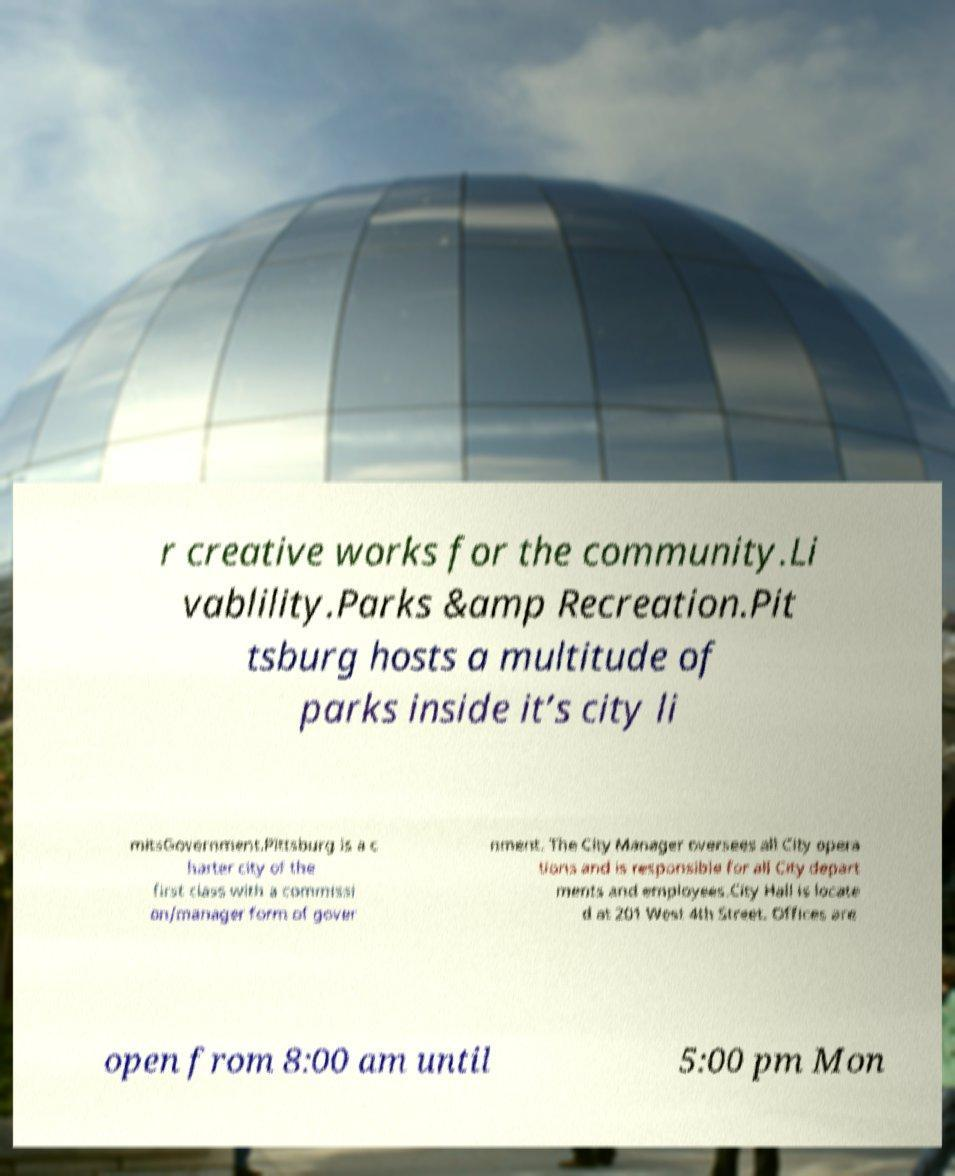Please identify and transcribe the text found in this image. r creative works for the community.Li vablility.Parks &amp Recreation.Pit tsburg hosts a multitude of parks inside it’s city li mitsGovernment.Pittsburg is a c harter city of the first class with a commissi on/manager form of gover nment. The City Manager oversees all City opera tions and is responsible for all City depart ments and employees.City Hall is locate d at 201 West 4th Street. Offices are open from 8:00 am until 5:00 pm Mon 